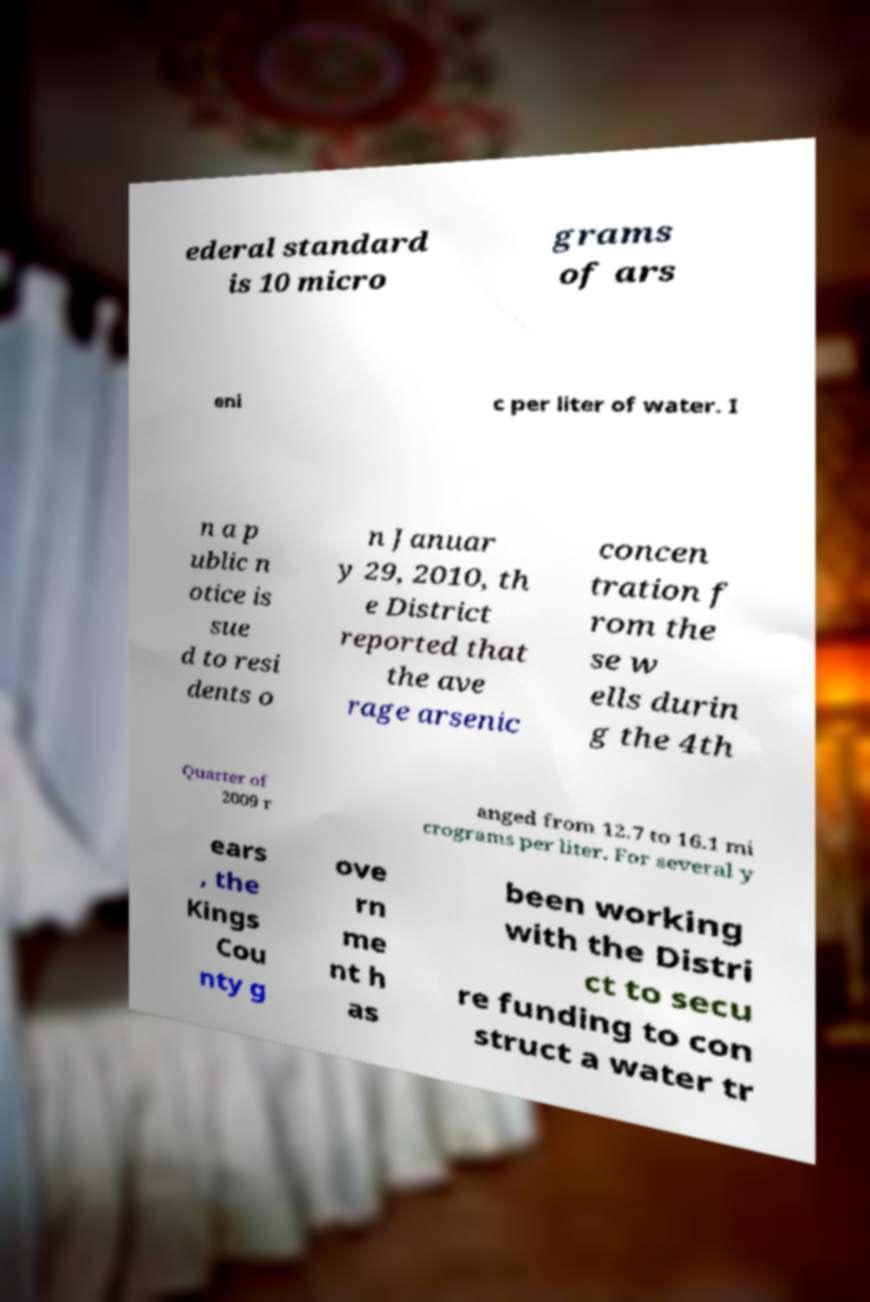What messages or text are displayed in this image? I need them in a readable, typed format. ederal standard is 10 micro grams of ars eni c per liter of water. I n a p ublic n otice is sue d to resi dents o n Januar y 29, 2010, th e District reported that the ave rage arsenic concen tration f rom the se w ells durin g the 4th Quarter of 2009 r anged from 12.7 to 16.1 mi crograms per liter. For several y ears , the Kings Cou nty g ove rn me nt h as been working with the Distri ct to secu re funding to con struct a water tr 